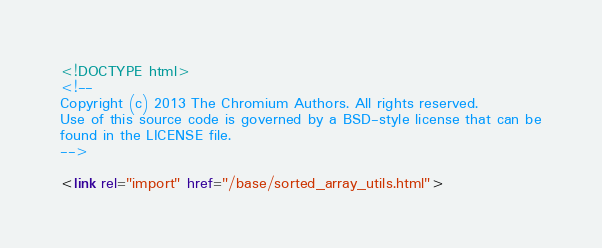Convert code to text. <code><loc_0><loc_0><loc_500><loc_500><_HTML_><!DOCTYPE html>
<!--
Copyright (c) 2013 The Chromium Authors. All rights reserved.
Use of this source code is governed by a BSD-style license that can be
found in the LICENSE file.
-->

<link rel="import" href="/base/sorted_array_utils.html"></code> 